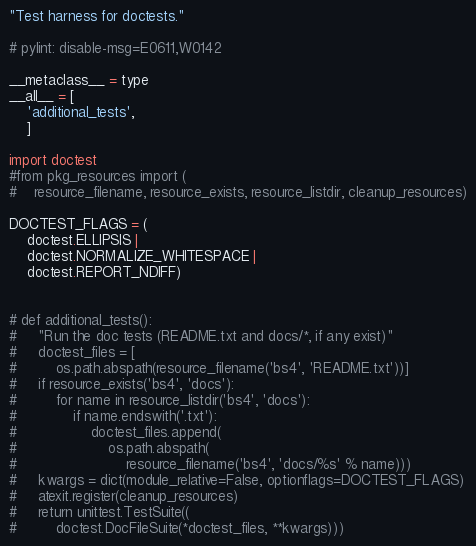Convert code to text. <code><loc_0><loc_0><loc_500><loc_500><_Python_>"Test harness for doctests."

# pylint: disable-msg=E0611,W0142

__metaclass__ = type
__all__ = [
    'additional_tests',
    ]

import doctest
#from pkg_resources import (
#    resource_filename, resource_exists, resource_listdir, cleanup_resources)

DOCTEST_FLAGS = (
    doctest.ELLIPSIS |
    doctest.NORMALIZE_WHITESPACE |
    doctest.REPORT_NDIFF)


# def additional_tests():
#     "Run the doc tests (README.txt and docs/*, if any exist)"
#     doctest_files = [
#         os.path.abspath(resource_filename('bs4', 'README.txt'))]
#     if resource_exists('bs4', 'docs'):
#         for name in resource_listdir('bs4', 'docs'):
#             if name.endswith('.txt'):
#                 doctest_files.append(
#                     os.path.abspath(
#                         resource_filename('bs4', 'docs/%s' % name)))
#     kwargs = dict(module_relative=False, optionflags=DOCTEST_FLAGS)
#     atexit.register(cleanup_resources)
#     return unittest.TestSuite((
#         doctest.DocFileSuite(*doctest_files, **kwargs)))
</code> 